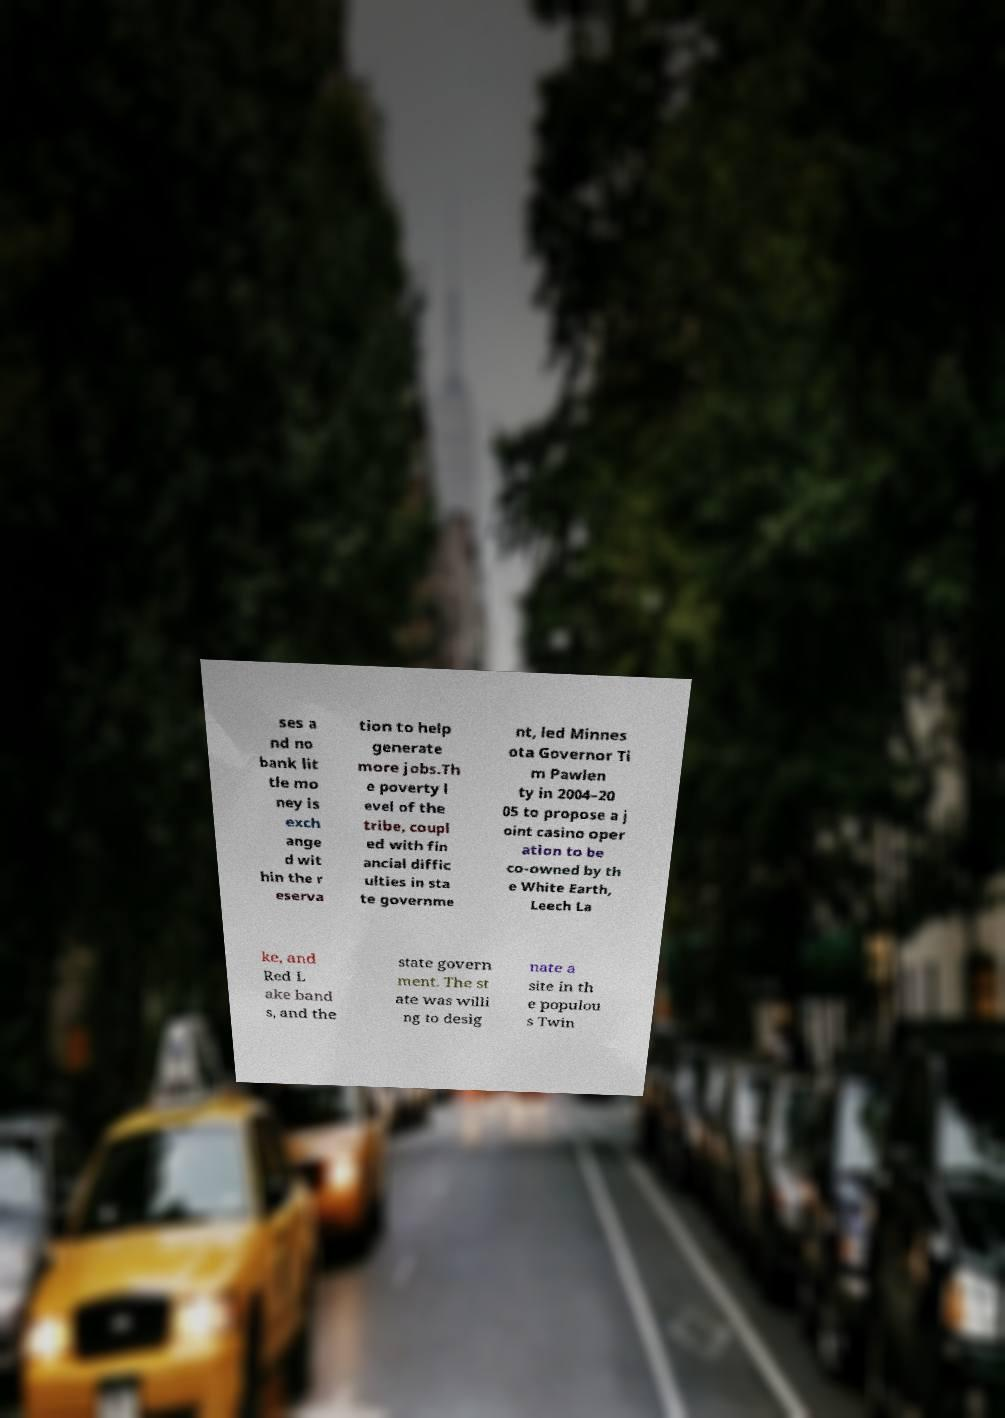Could you assist in decoding the text presented in this image and type it out clearly? ses a nd no bank lit tle mo ney is exch ange d wit hin the r eserva tion to help generate more jobs.Th e poverty l evel of the tribe, coupl ed with fin ancial diffic ulties in sta te governme nt, led Minnes ota Governor Ti m Pawlen ty in 2004–20 05 to propose a j oint casino oper ation to be co-owned by th e White Earth, Leech La ke, and Red L ake band s, and the state govern ment. The st ate was willi ng to desig nate a site in th e populou s Twin 